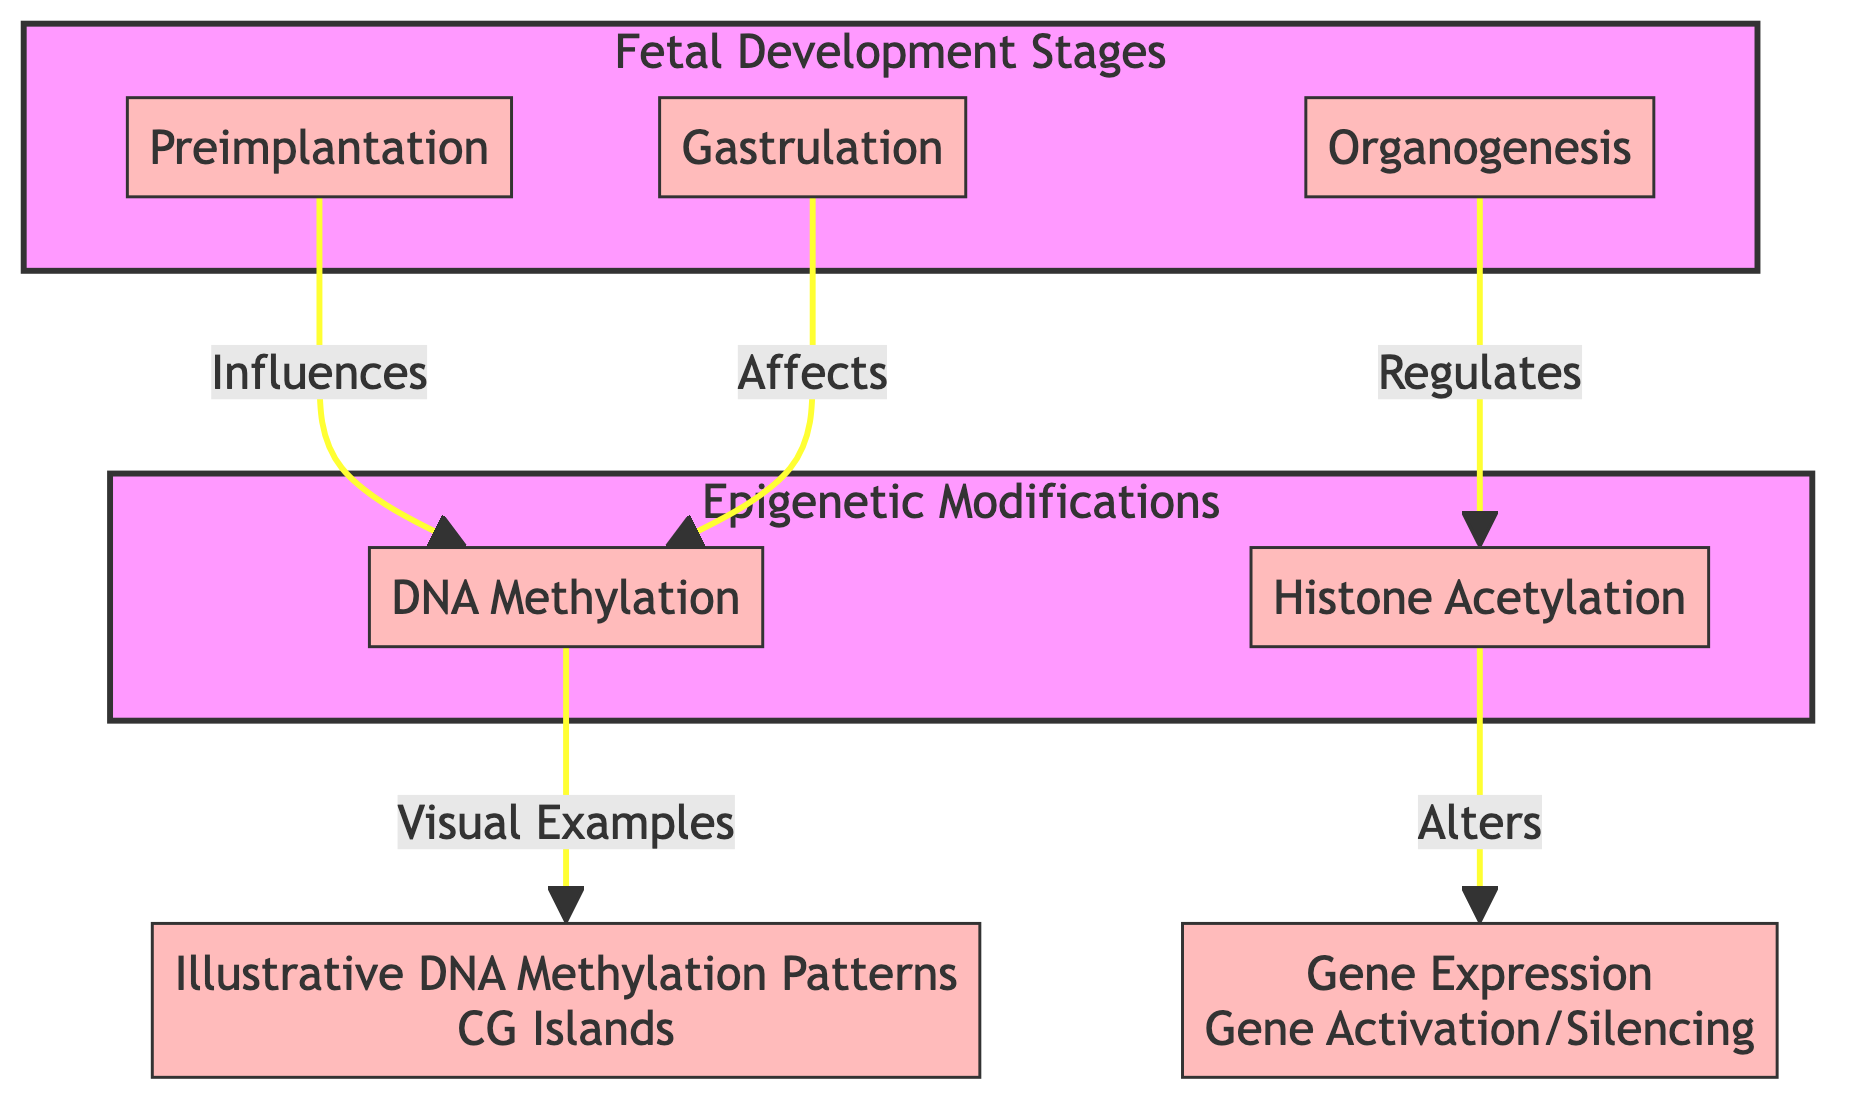What are the three stages of fetal development depicted? The diagram lists three stages of fetal development: Preimplantation, Gastrulation, and Organogenesis. These stages are represented as nodes under the "Fetal Development Stages" subgraph.
Answer: Preimplantation, Gastrulation, Organogenesis How many types of epigenetic modifications are shown? The diagram illustrates two types of epigenetic modifications: DNA Methylation and Histone Acetylation. This information is found in the "Epigenetic Modifications" subgraph.
Answer: Two Which fetal development stage influences DNA methylation? The Preimplantation stage is depicted as influencing DNA methylation in the diagram. This is indicated by the directional arrow connecting Preimplantation to DNA Methylation.
Answer: Preimplantation What impact does organogenesis have on histone acetylation? Organogenesis is shown to regulate histone acetylation according to the directional arrow in the diagram connecting Organogenesis to Histone Acetylation. This suggests that organogenesis has a regulatory effect on this epigenetic modification.
Answer: Regulates What follows after DNA methylation in the diagram? The diagram indicates that DNA methylation leads to visual examples of illustrative DNA methylation patterns, specifically related to CG islands, as indicated by the connection from DNA Methylation to Illustrative DNA Methylation Patterns.
Answer: Visual Examples How does histone acetylation affect gene expression? The diagram shows that histone acetylation alters gene expression, indicating a direct effect of histone acetylation on gene activation or silencing. This relationship is represented by the arrow from Histone Acetylation to Gene Expression.
Answer: Alters What type of arrows are used to represent influences, effects, and regulations? The arrows in the diagram are visually represented with a stroke style indicating the nature of the interaction, and all arrows have a consistent stroke color and width. They denote various relationships, such as influence or regulation, between nodes.
Answer: Consistent stroke style What are the illustrative DNA methylation patterns specifically related to? The diagram specifies that the illustrative DNA methylation patterns are specifically related to CG islands. This relationship is represented by the label in the node connected to DNA Methylation.
Answer: CG Islands 